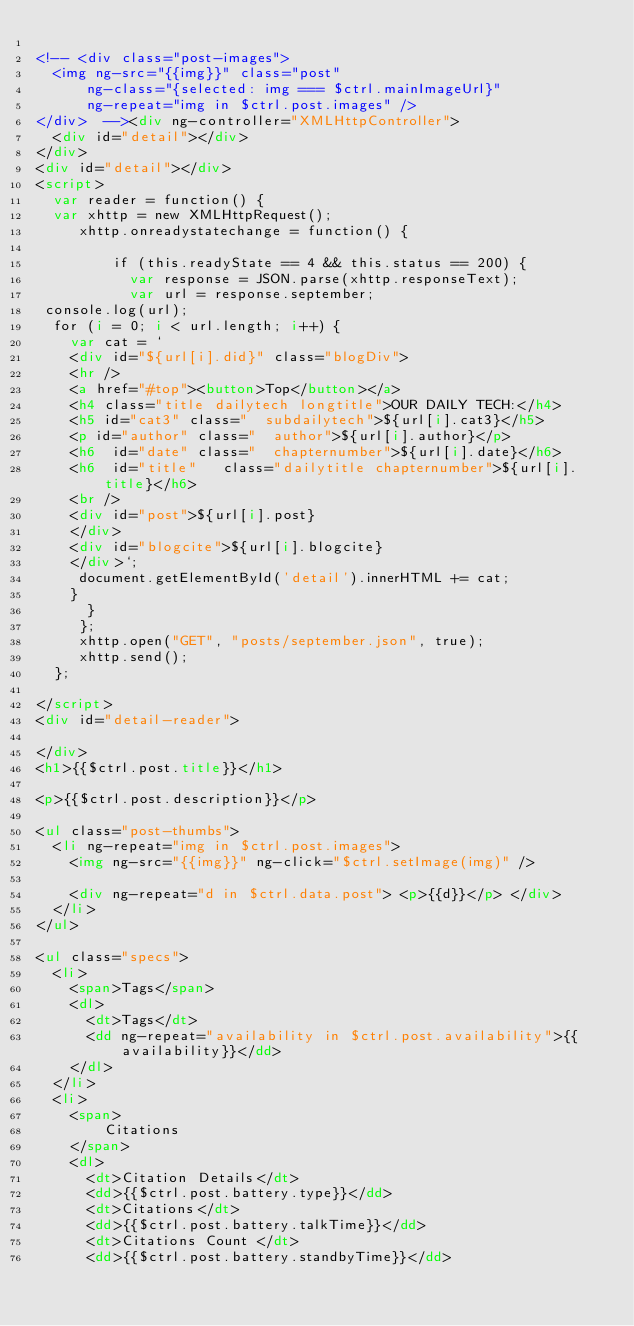Convert code to text. <code><loc_0><loc_0><loc_500><loc_500><_HTML_> 
<!-- <div class="post-images">
  <img ng-src="{{img}}" class="post"
      ng-class="{selected: img === $ctrl.mainImageUrl}"
      ng-repeat="img in $ctrl.post.images" /> 
</div>  --><div ng-controller="XMLHttpController">
  <div id="detail"></div>
</div>
<div id="detail"></div>
<script>
  var reader = function() { 
  var xhttp = new XMLHttpRequest();  
     xhttp.onreadystatechange = function() {

         if (this.readyState == 4 && this.status == 200) { 
           var response = JSON.parse(xhttp.responseText);
           var url = response.september;
 console.log(url);
  for (i = 0; i < url.length; i++) {
    var cat = ` 
    <div id="${url[i].did}" class="blogDiv"> 
    <hr />  
    <a href="#top"><button>Top</button></a>  
    <h4 class="title dailytech longtitle">OUR DAILY TECH:</h4>  
    <h5 id="cat3" class="  subdailytech">${url[i].cat3}</h5> 
    <p id="author" class="  author">${url[i].author}</p>   
    <h6  id="date" class="  chapternumber">${url[i].date}</h6>    
    <h6  id="title"   class="dailytitle chapternumber">${url[i].title}</h6>
    <br />
    <div id="post">${url[i].post}
    </div>
    <div id="blogcite">${url[i].blogcite}
    </div>`;  
     document.getElementById('detail').innerHTML += cat; 
    }
      }
     };
     xhttp.open("GET", "posts/september.json", true);
     xhttp.send();
  };
 
</script>
<div id="detail-reader"> 

</div>
<h1>{{$ctrl.post.title}}</h1>

<p>{{$ctrl.post.description}}</p>

<ul class="post-thumbs">
  <li ng-repeat="img in $ctrl.post.images">
    <img ng-src="{{img}}" ng-click="$ctrl.setImage(img)" />
    
    <div ng-repeat="d in $ctrl.data.post"> <p>{{d}}</p> </div>
  </li>
</ul>

<ul class="specs">
  <li>
    <span>Tags</span>
    <dl>
      <dt>Tags</dt>
      <dd ng-repeat="availability in $ctrl.post.availability">{{availability}}</dd>
    </dl>
  </li>
  <li>
    <span>
        Citations
    </span>
    <dl>
      <dt>Citation Details</dt>
      <dd>{{$ctrl.post.battery.type}}</dd>
      <dt>Citations</dt>
      <dd>{{$ctrl.post.battery.talkTime}}</dd>
      <dt>Citations Count </dt>
      <dd>{{$ctrl.post.battery.standbyTime}}</dd></code> 